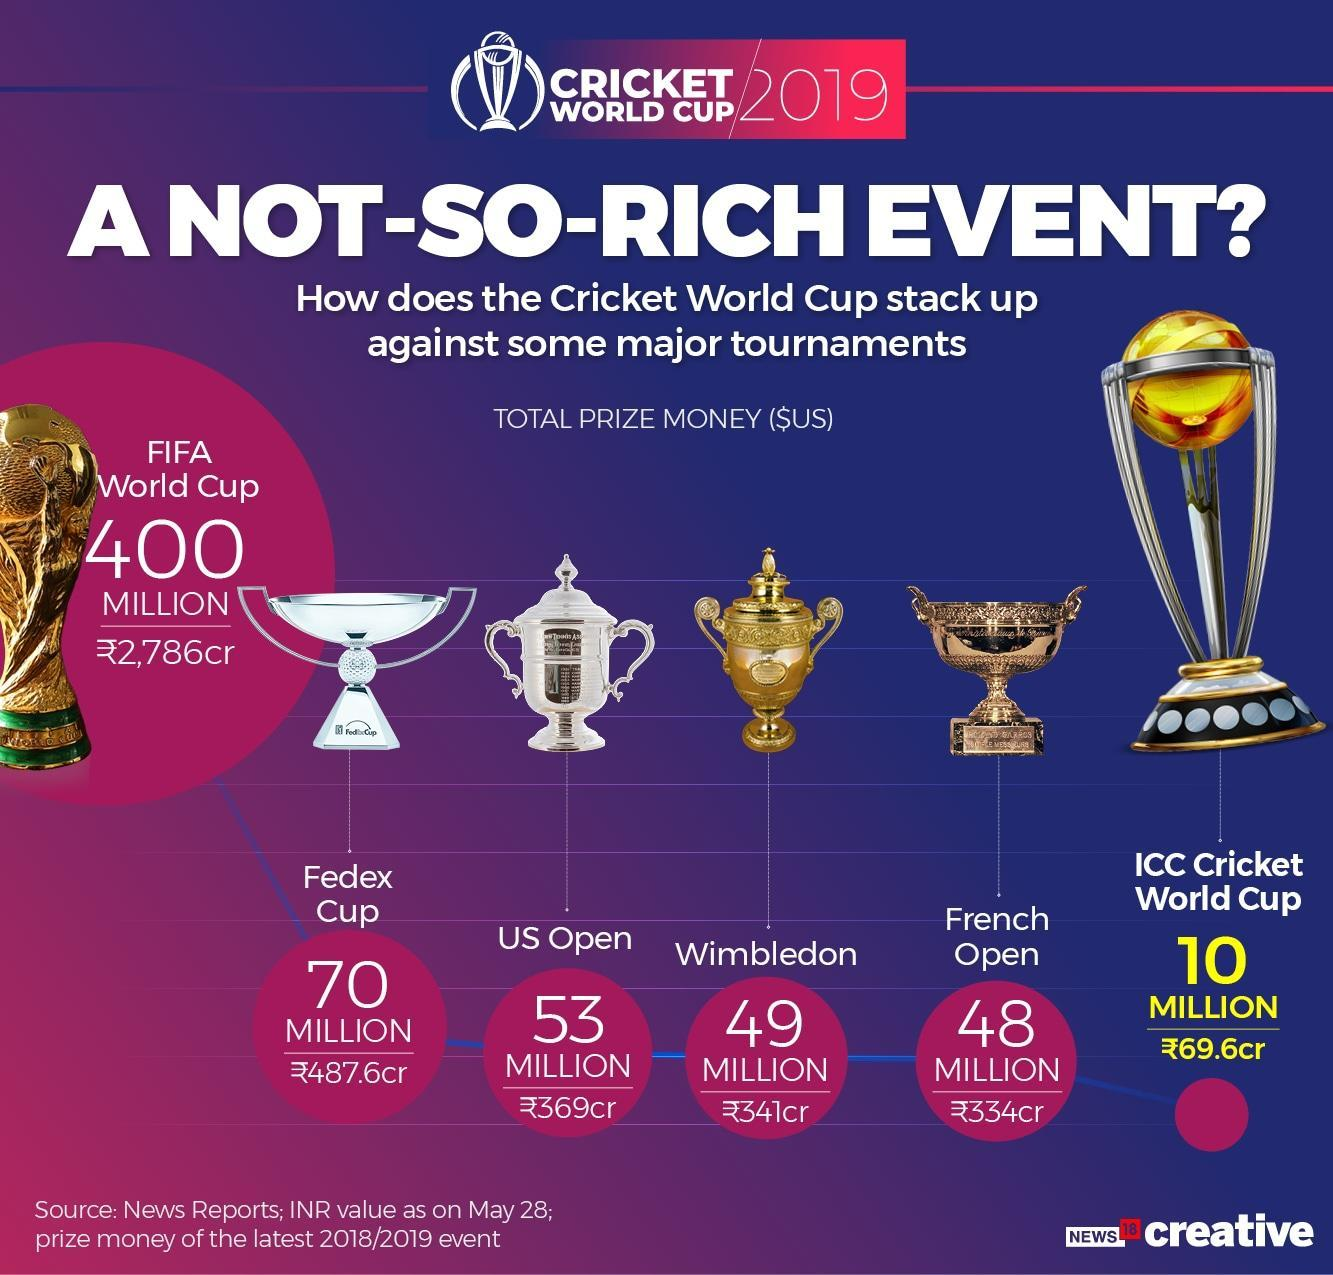What is the total prize money for Wimbledon?
Answer the question with a short phrase. 49 million Which tennis tournament has the highest prize money? US Open What is the total prize money for the US open? 53 million How many major tennis tournaments mentioned in this infographic? 3 What is the color of the Wimbledon trophy-silver, gold, bronze? gold 